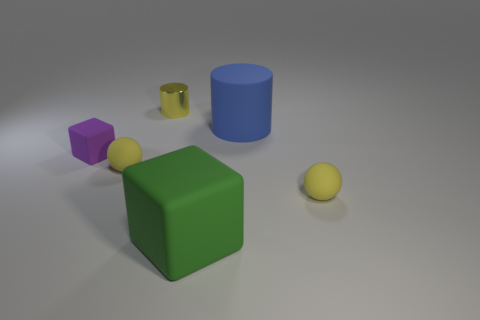If this image is part of a larger story, what do you think it could be? Given the simplicity and the variety of shapes and colors, one might imagine this image as part of an educational story, perhaps teaching children about geometry, colors, and sizes. Alternatively, it could be a snapshot from a designer's project focusing on 3D modeling and material properties in a virtual environment. 